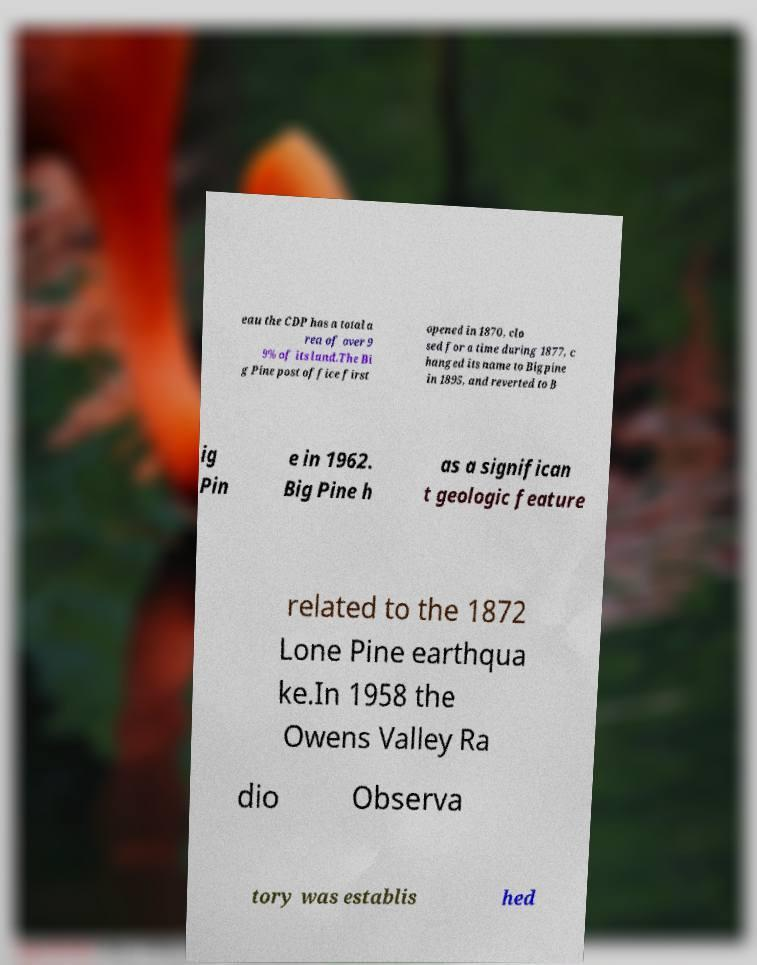Please read and relay the text visible in this image. What does it say? eau the CDP has a total a rea of over 9 9% of its land.The Bi g Pine post office first opened in 1870, clo sed for a time during 1877, c hanged its name to Bigpine in 1895, and reverted to B ig Pin e in 1962. Big Pine h as a significan t geologic feature related to the 1872 Lone Pine earthqua ke.In 1958 the Owens Valley Ra dio Observa tory was establis hed 